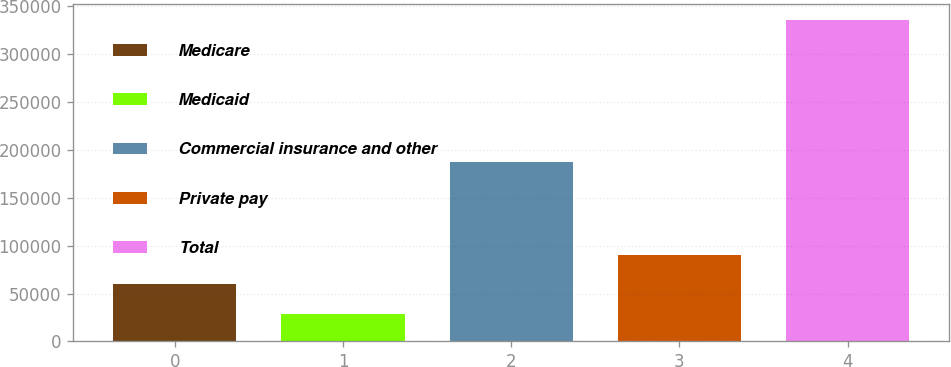Convert chart to OTSL. <chart><loc_0><loc_0><loc_500><loc_500><bar_chart><fcel>Medicare<fcel>Medicaid<fcel>Commercial insurance and other<fcel>Private pay<fcel>Total<nl><fcel>59742.1<fcel>29072<fcel>187273<fcel>90412.2<fcel>335773<nl></chart> 